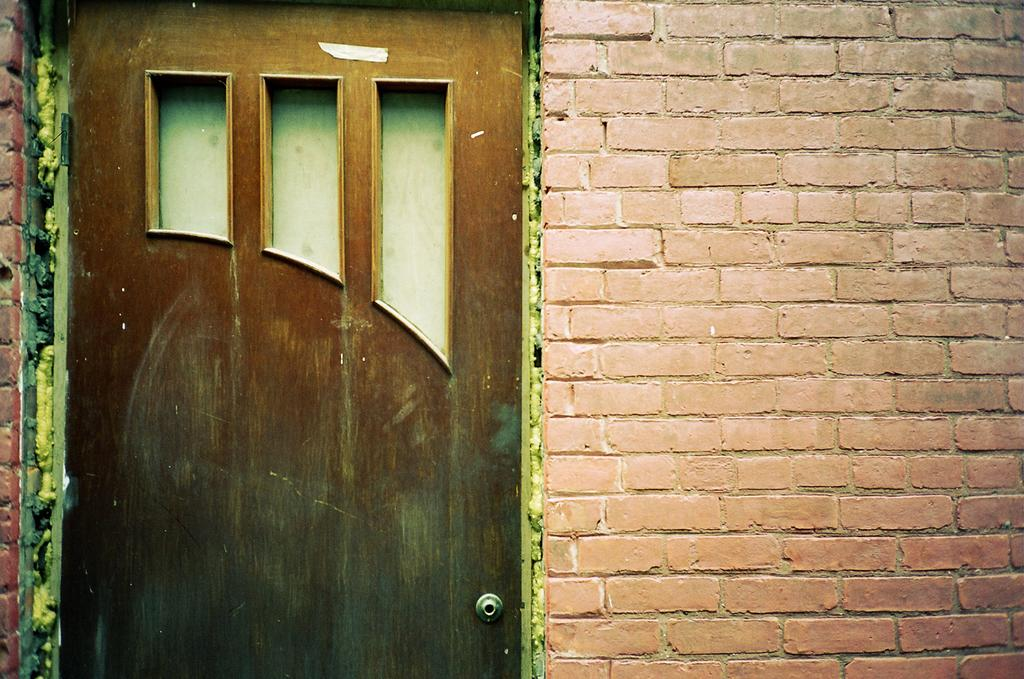What type of door is visible in the image? There is a closed wooden door in the image. What can be seen on the wall in the image? The wall in the image has red bricks. What book is the tree reading in the image? There is no book or tree present in the image. How does the wall change color throughout the day in the image? The wall's color does not change throughout the day in the image; it remains red brick. 